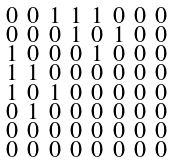<formula> <loc_0><loc_0><loc_500><loc_500>\begin{smallmatrix} 0 & 0 & 1 & 1 & 1 & 0 & 0 & 0 \\ 0 & 0 & 0 & 1 & 0 & 1 & 0 & 0 \\ 1 & 0 & 0 & 0 & 1 & 0 & 0 & 0 \\ 1 & 1 & 0 & 0 & 0 & 0 & 0 & 0 \\ 1 & 0 & 1 & 0 & 0 & 0 & 0 & 0 \\ 0 & 1 & 0 & 0 & 0 & 0 & 0 & 0 \\ 0 & 0 & 0 & 0 & 0 & 0 & 0 & 0 \\ 0 & 0 & 0 & 0 & 0 & 0 & 0 & 0 \end{smallmatrix}</formula> 